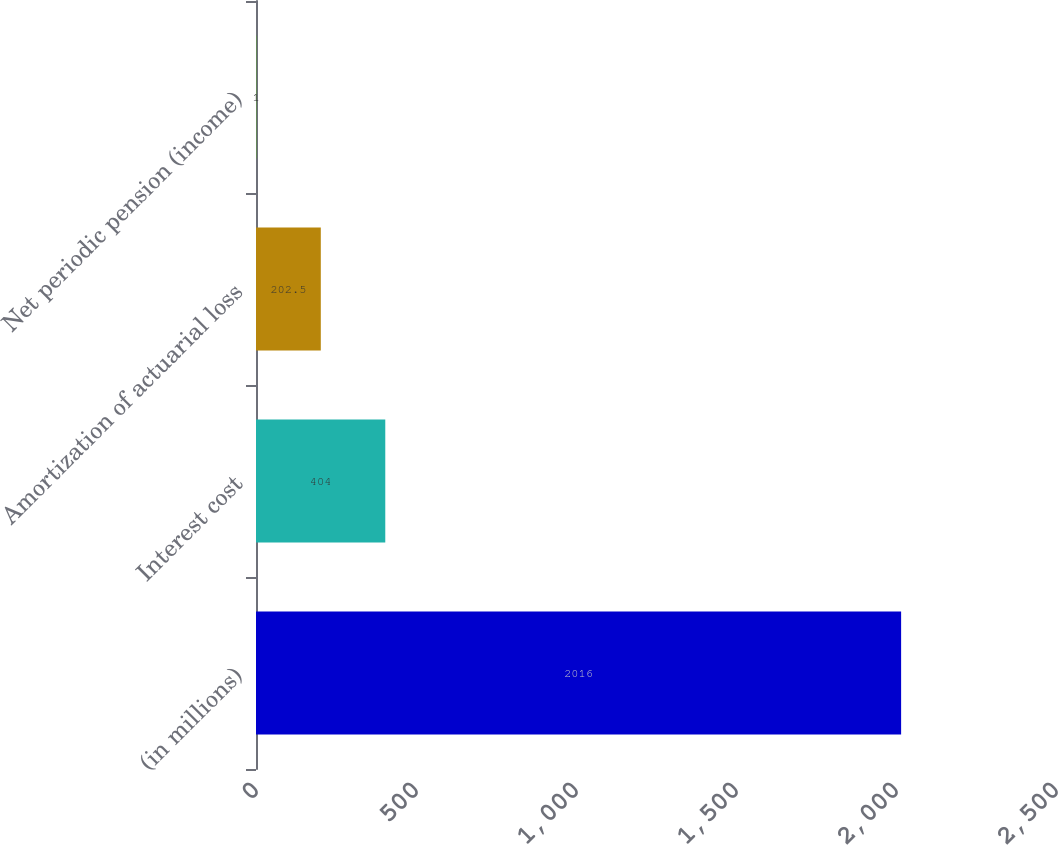Convert chart to OTSL. <chart><loc_0><loc_0><loc_500><loc_500><bar_chart><fcel>(in millions)<fcel>Interest cost<fcel>Amortization of actuarial loss<fcel>Net periodic pension (income)<nl><fcel>2016<fcel>404<fcel>202.5<fcel>1<nl></chart> 